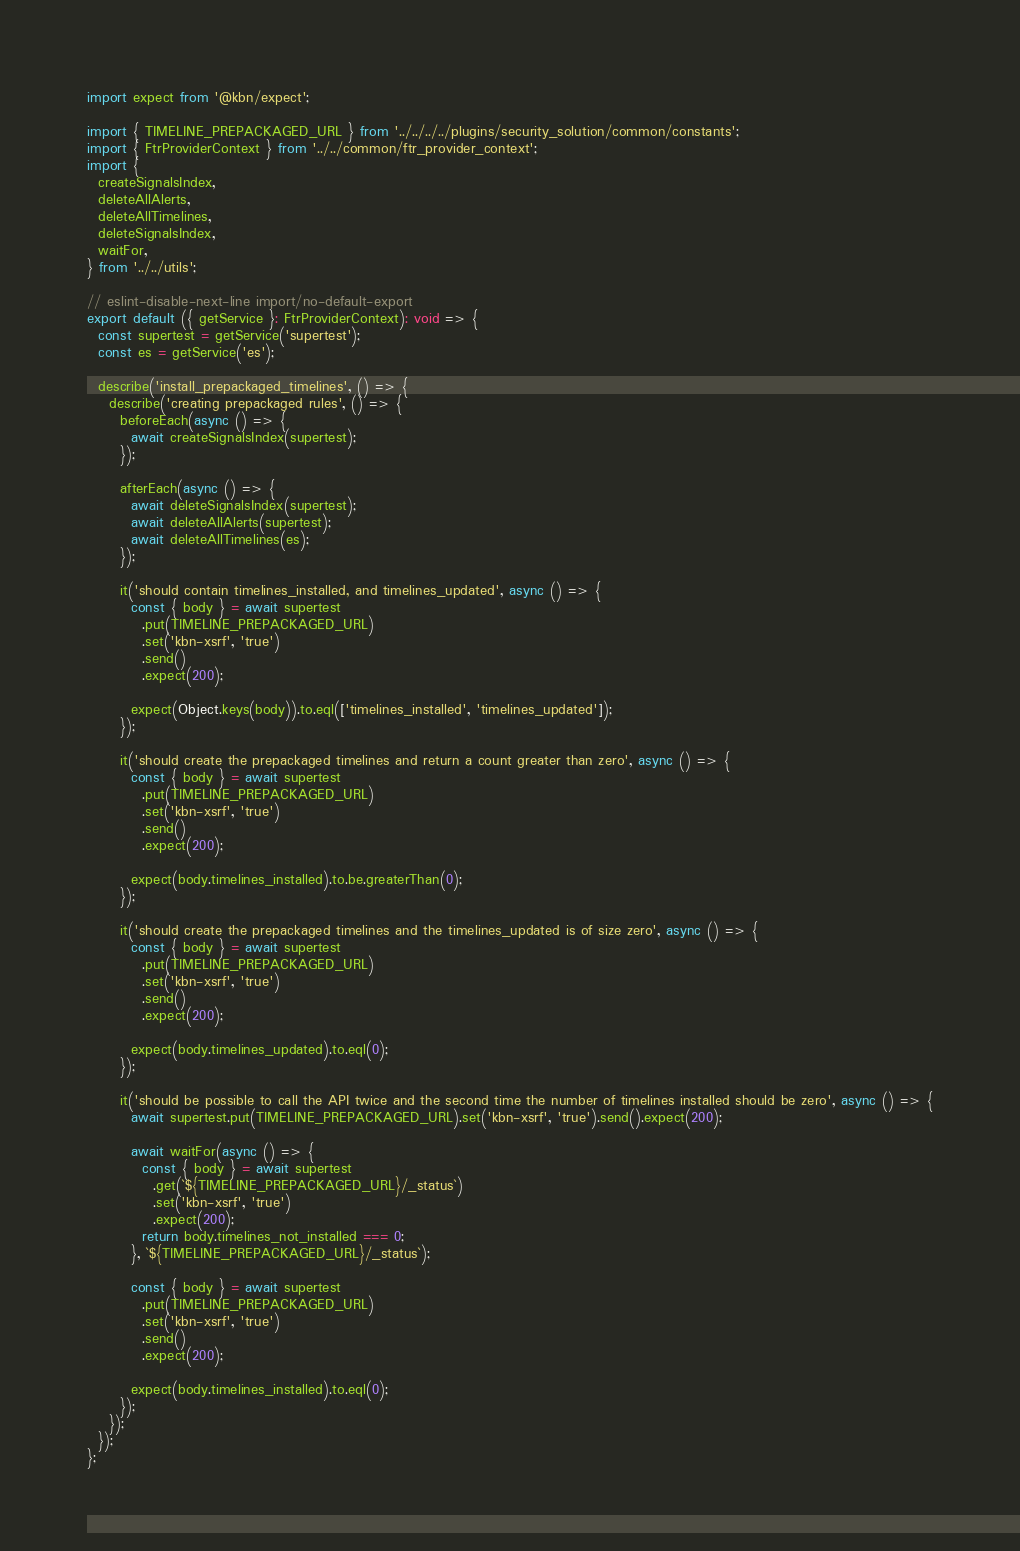<code> <loc_0><loc_0><loc_500><loc_500><_TypeScript_>
import expect from '@kbn/expect';

import { TIMELINE_PREPACKAGED_URL } from '../../../../plugins/security_solution/common/constants';
import { FtrProviderContext } from '../../common/ftr_provider_context';
import {
  createSignalsIndex,
  deleteAllAlerts,
  deleteAllTimelines,
  deleteSignalsIndex,
  waitFor,
} from '../../utils';

// eslint-disable-next-line import/no-default-export
export default ({ getService }: FtrProviderContext): void => {
  const supertest = getService('supertest');
  const es = getService('es');

  describe('install_prepackaged_timelines', () => {
    describe('creating prepackaged rules', () => {
      beforeEach(async () => {
        await createSignalsIndex(supertest);
      });

      afterEach(async () => {
        await deleteSignalsIndex(supertest);
        await deleteAllAlerts(supertest);
        await deleteAllTimelines(es);
      });

      it('should contain timelines_installed, and timelines_updated', async () => {
        const { body } = await supertest
          .put(TIMELINE_PREPACKAGED_URL)
          .set('kbn-xsrf', 'true')
          .send()
          .expect(200);

        expect(Object.keys(body)).to.eql(['timelines_installed', 'timelines_updated']);
      });

      it('should create the prepackaged timelines and return a count greater than zero', async () => {
        const { body } = await supertest
          .put(TIMELINE_PREPACKAGED_URL)
          .set('kbn-xsrf', 'true')
          .send()
          .expect(200);

        expect(body.timelines_installed).to.be.greaterThan(0);
      });

      it('should create the prepackaged timelines and the timelines_updated is of size zero', async () => {
        const { body } = await supertest
          .put(TIMELINE_PREPACKAGED_URL)
          .set('kbn-xsrf', 'true')
          .send()
          .expect(200);

        expect(body.timelines_updated).to.eql(0);
      });

      it('should be possible to call the API twice and the second time the number of timelines installed should be zero', async () => {
        await supertest.put(TIMELINE_PREPACKAGED_URL).set('kbn-xsrf', 'true').send().expect(200);

        await waitFor(async () => {
          const { body } = await supertest
            .get(`${TIMELINE_PREPACKAGED_URL}/_status`)
            .set('kbn-xsrf', 'true')
            .expect(200);
          return body.timelines_not_installed === 0;
        }, `${TIMELINE_PREPACKAGED_URL}/_status`);

        const { body } = await supertest
          .put(TIMELINE_PREPACKAGED_URL)
          .set('kbn-xsrf', 'true')
          .send()
          .expect(200);

        expect(body.timelines_installed).to.eql(0);
      });
    });
  });
};
</code> 